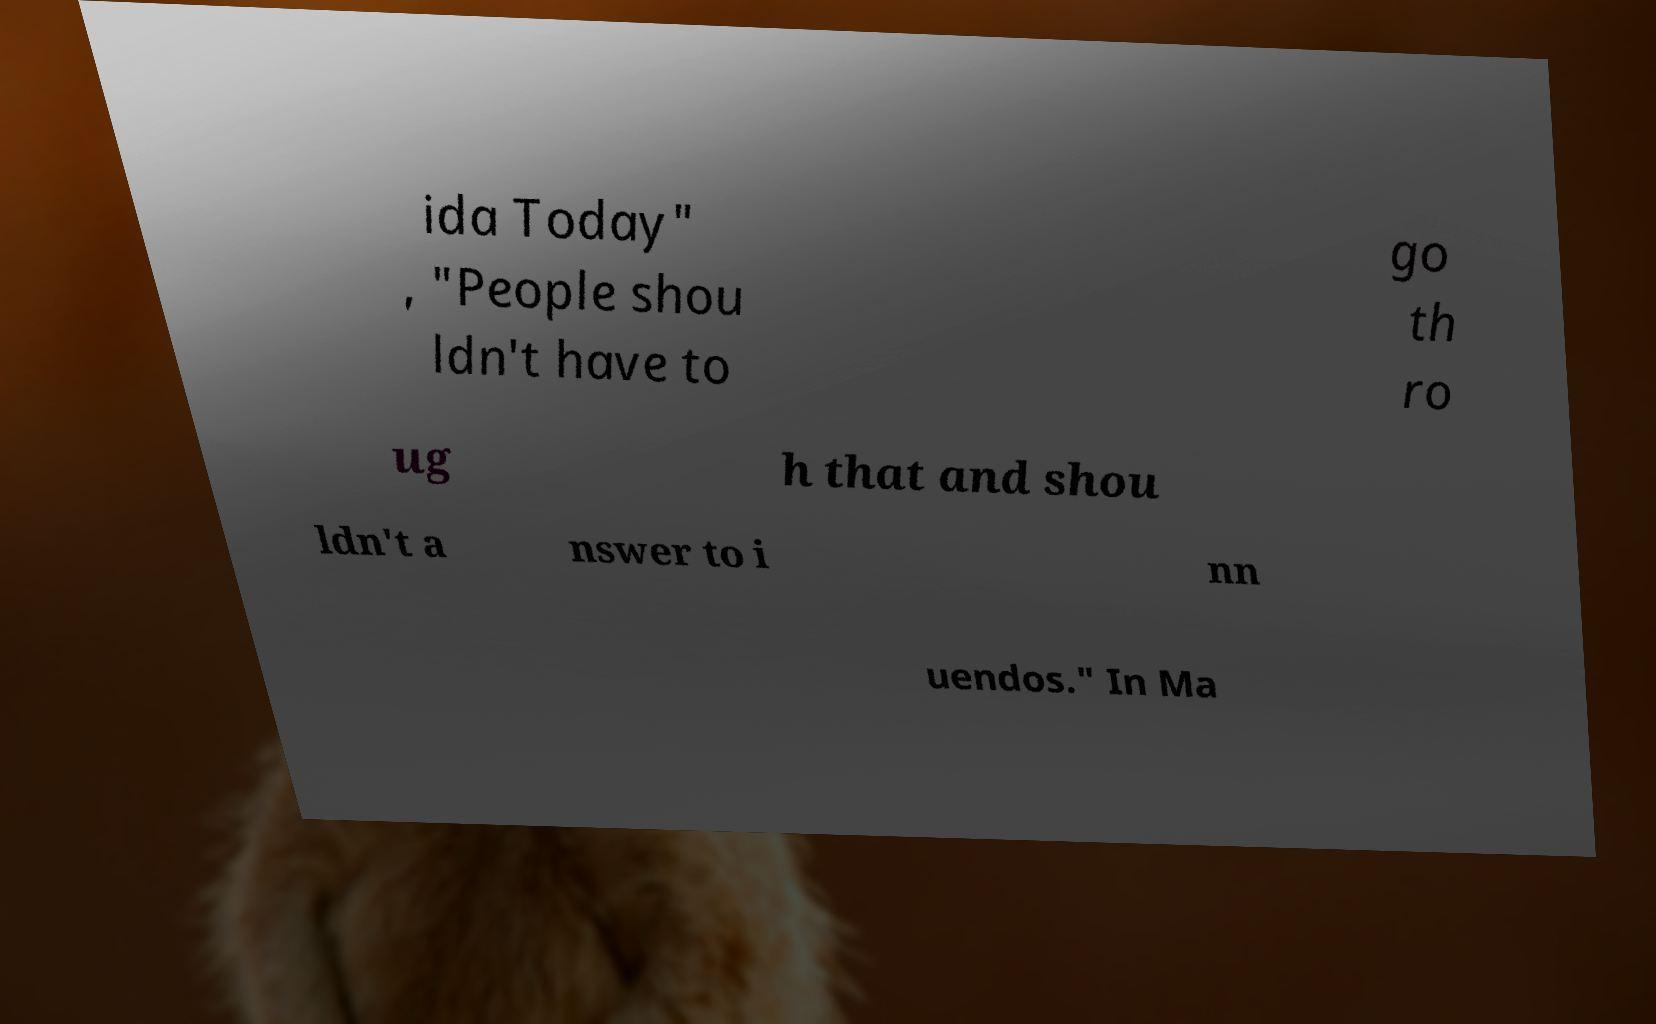There's text embedded in this image that I need extracted. Can you transcribe it verbatim? ida Today" , "People shou ldn't have to go th ro ug h that and shou ldn't a nswer to i nn uendos." In Ma 